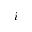<formula> <loc_0><loc_0><loc_500><loc_500>i</formula> 